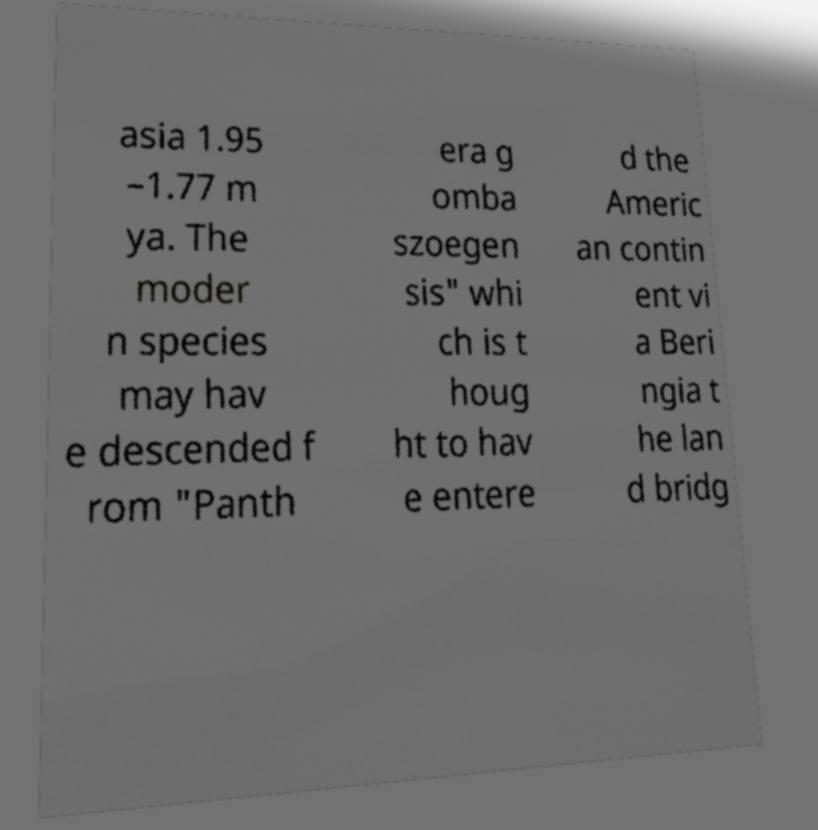Please identify and transcribe the text found in this image. asia 1.95 –1.77 m ya. The moder n species may hav e descended f rom "Panth era g omba szoegen sis" whi ch is t houg ht to hav e entere d the Americ an contin ent vi a Beri ngia t he lan d bridg 